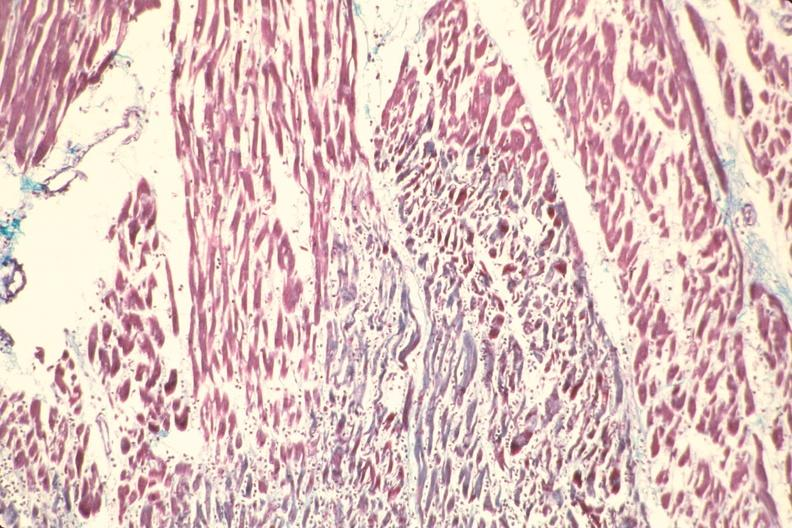what stain?
Answer the question using a single word or phrase. Heart, acute myocardial infarction, aldehyde fuscin 